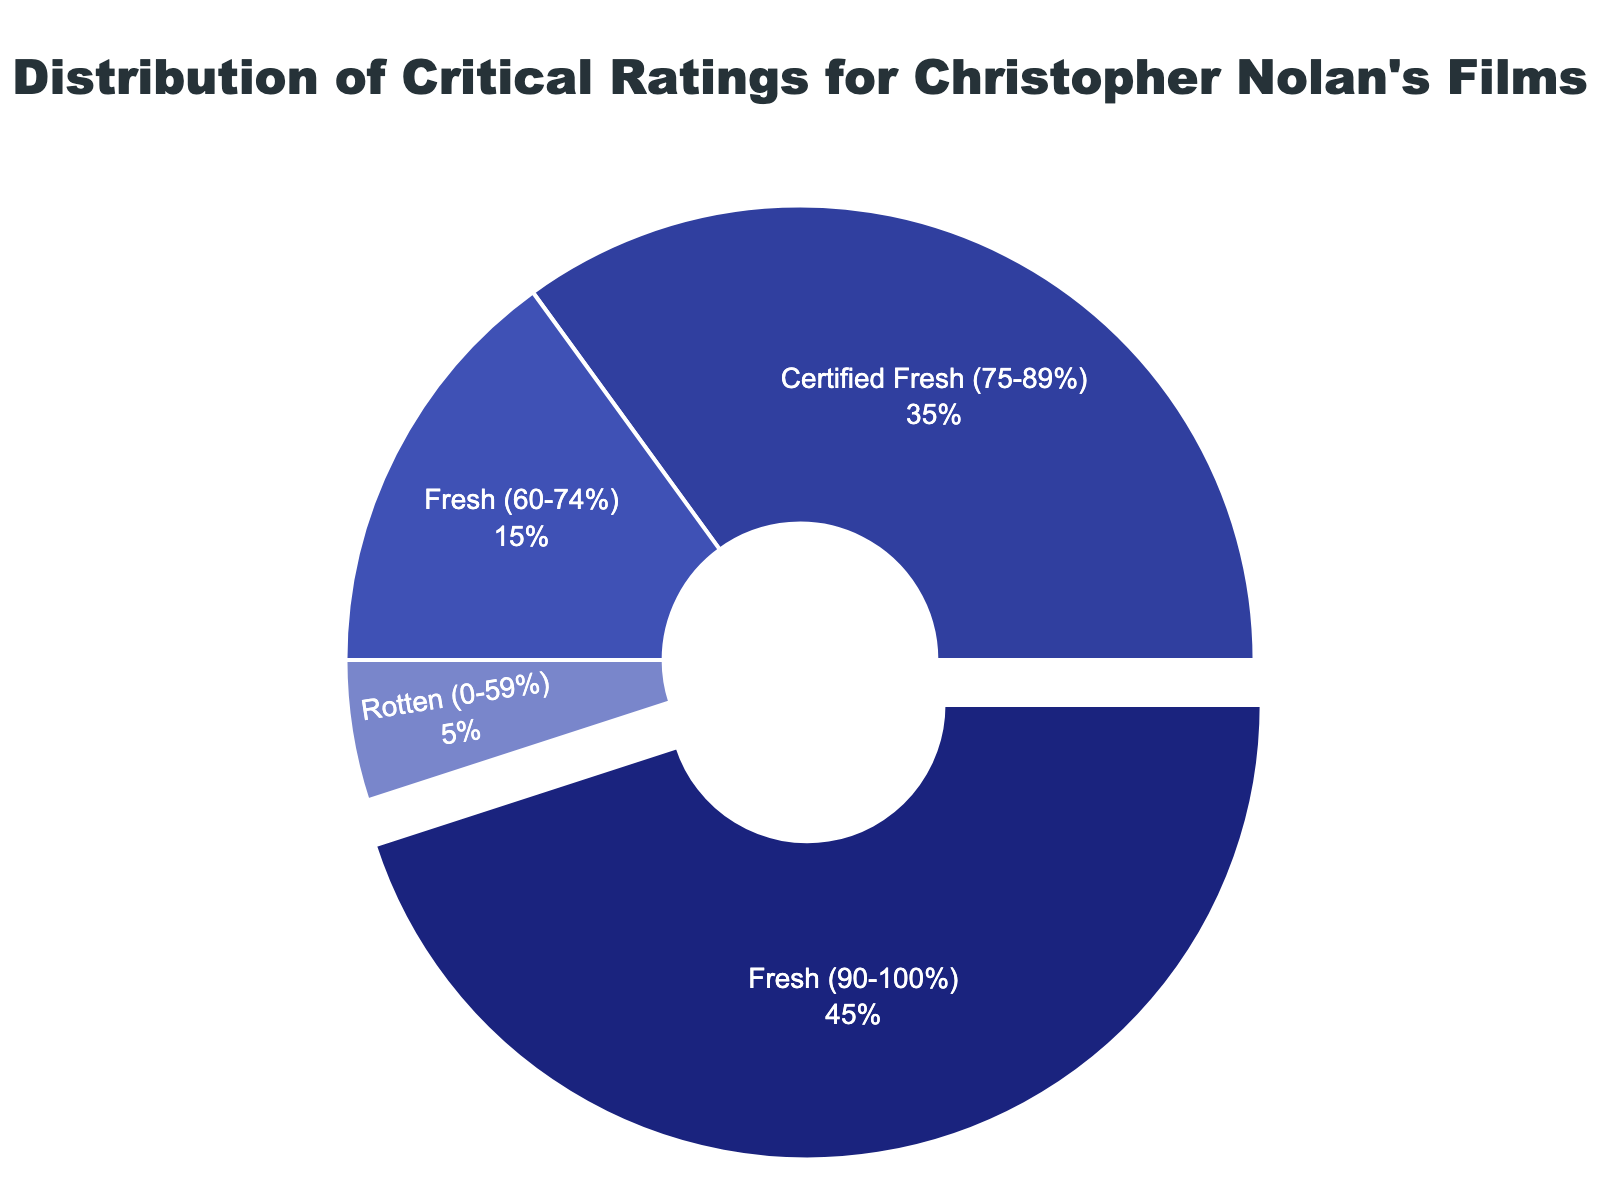what is the percentage of Nolan's films rated 'Certified Fresh'? The 'Certified Fresh' category represents 35% of the pie chart.
Answer: 35% How do the combined percentages of 'Fresh' (90-100%) and 'Certified Fresh' compare to the percentage of 'Fresh' (60-74%)? The combined percentage of 'Fresh' (90-100%) and 'Certified Fresh' is 45% + 35% = 80%, which is significantly higher compared to the 'Fresh' (60-74%) category at 15%.
Answer: 80% vs 15% Which category has the smallest proportion of Nolan's films? The 'Rotten' category has the smallest proportion at 5%.
Answer: 5% What percentage of Nolan's films are rated 'Fresh' (either '90-100%' or '60-74%')? The combined percentage of 'Fresh' ratings (90-100%) and (60-74%) is 45% + 15%, which equals 60%.
Answer: 60% How many times larger is the 'Certified Fresh' category compared to the 'Rotten' category? The percentage of the 'Certified Fresh' category is 35%, and the 'Rotten' category is 5%. So, 35% / 5% = 7 times larger.
Answer: 7 times What is the most frequent critical rating for Christopher Nolan's films? The 'Fresh' (90-100%) category has the highest percentage at 45%.
Answer: Fresh (90-100%) What is the combined percentage of 'Rotten' and 'Fresh' (60-74%)? The combined percentage of 'Rotten' and 'Fresh' (60-74%) is 5% + 15% = 20%.
Answer: 20% If the pie chart was divided into two main parts: one including all 'Fresh' ratings and the other including 'Rotten', what would be the percentage division? All 'Fresh' ratings combined would be 45% (90-100%) + 35% (75-89%) + 15% (60-74%), which equals 95%. The 'Rotten' category is 5%, making the division 95% for 'Fresh' and 5% for 'Rotten'.
Answer: 95% vs 5% Which category follows the 'Fresh' (90-100%) in terms of percentage and by how much percentage difference? The 'Certified Fresh' (75-89%) category follows with 35%, which is 10% less than the 'Fresh' (90-100%) category at 45%.
Answer: Certified Fresh (75-89%) and 10% What percentage of Nolan's films were not rated as 'Fresh' (90-100%)? The remaining categories (Certified Fresh, Fresh (60-74%), and Rotten) together constitute 55%.
Answer: 55% 